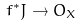Convert formula to latex. <formula><loc_0><loc_0><loc_500><loc_500>f ^ { * } J \rightarrow O _ { X }</formula> 